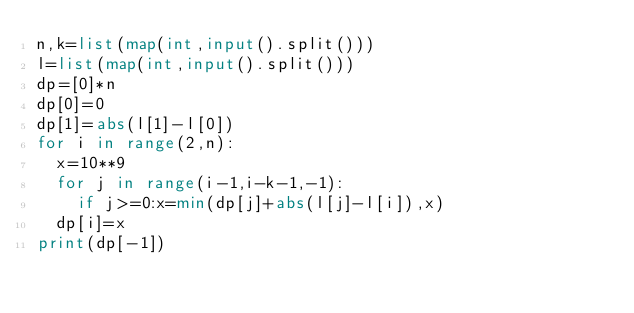Convert code to text. <code><loc_0><loc_0><loc_500><loc_500><_Python_>n,k=list(map(int,input().split()))
l=list(map(int,input().split()))
dp=[0]*n
dp[0]=0
dp[1]=abs(l[1]-l[0])
for i in range(2,n):
	x=10**9
	for j in range(i-1,i-k-1,-1):
		if j>=0:x=min(dp[j]+abs(l[j]-l[i]),x)
	dp[i]=x
print(dp[-1])
</code> 